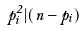<formula> <loc_0><loc_0><loc_500><loc_500>p _ { i } ^ { 2 } | ( n - p _ { i } )</formula> 